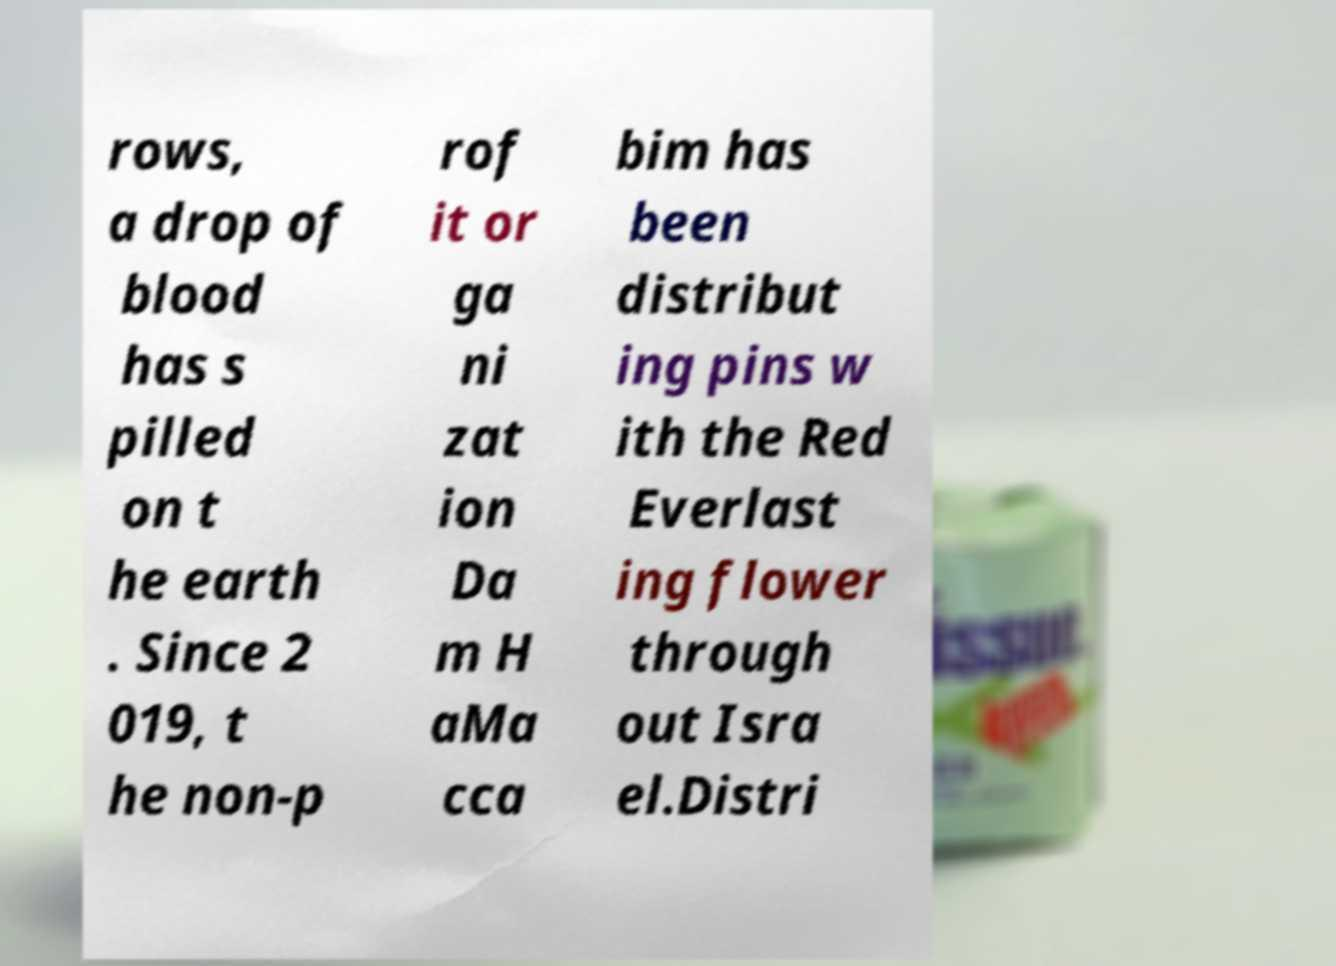For documentation purposes, I need the text within this image transcribed. Could you provide that? rows, a drop of blood has s pilled on t he earth . Since 2 019, t he non-p rof it or ga ni zat ion Da m H aMa cca bim has been distribut ing pins w ith the Red Everlast ing flower through out Isra el.Distri 